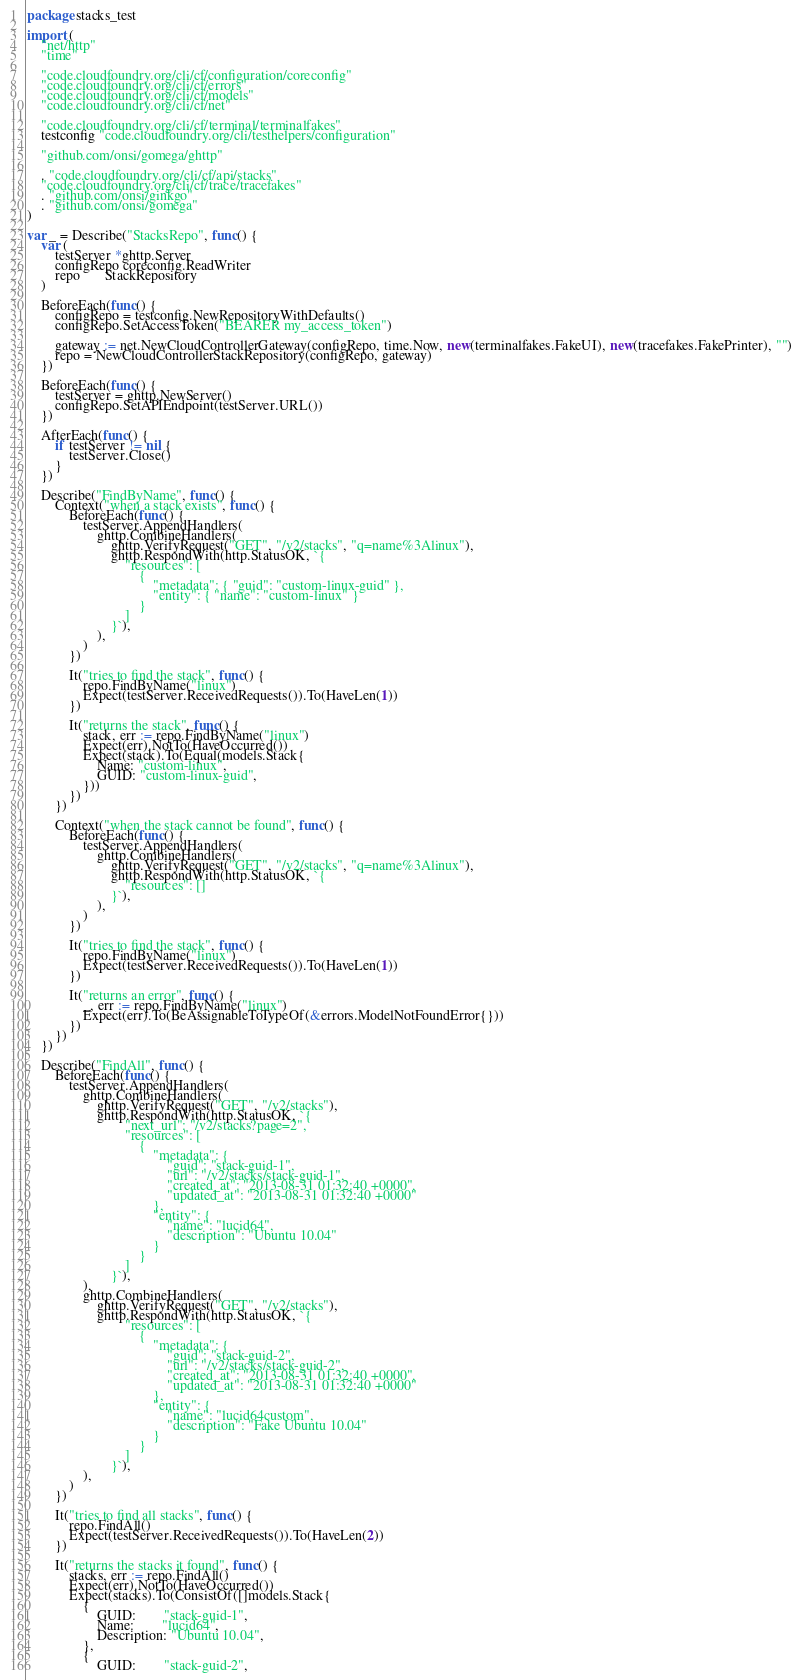Convert code to text. <code><loc_0><loc_0><loc_500><loc_500><_Go_>package stacks_test

import (
	"net/http"
	"time"

	"code.cloudfoundry.org/cli/cf/configuration/coreconfig"
	"code.cloudfoundry.org/cli/cf/errors"
	"code.cloudfoundry.org/cli/cf/models"
	"code.cloudfoundry.org/cli/cf/net"

	"code.cloudfoundry.org/cli/cf/terminal/terminalfakes"
	testconfig "code.cloudfoundry.org/cli/testhelpers/configuration"

	"github.com/onsi/gomega/ghttp"

	. "code.cloudfoundry.org/cli/cf/api/stacks"
	"code.cloudfoundry.org/cli/cf/trace/tracefakes"
	. "github.com/onsi/ginkgo"
	. "github.com/onsi/gomega"
)

var _ = Describe("StacksRepo", func() {
	var (
		testServer *ghttp.Server
		configRepo coreconfig.ReadWriter
		repo       StackRepository
	)

	BeforeEach(func() {
		configRepo = testconfig.NewRepositoryWithDefaults()
		configRepo.SetAccessToken("BEARER my_access_token")

		gateway := net.NewCloudControllerGateway(configRepo, time.Now, new(terminalfakes.FakeUI), new(tracefakes.FakePrinter), "")
		repo = NewCloudControllerStackRepository(configRepo, gateway)
	})

	BeforeEach(func() {
		testServer = ghttp.NewServer()
		configRepo.SetAPIEndpoint(testServer.URL())
	})

	AfterEach(func() {
		if testServer != nil {
			testServer.Close()
		}
	})

	Describe("FindByName", func() {
		Context("when a stack exists", func() {
			BeforeEach(func() {
				testServer.AppendHandlers(
					ghttp.CombineHandlers(
						ghttp.VerifyRequest("GET", "/v2/stacks", "q=name%3Alinux"),
						ghttp.RespondWith(http.StatusOK, `{
							"resources": [
								{
									"metadata": { "guid": "custom-linux-guid" },
									"entity": { "name": "custom-linux" }
								}
							]
						}`),
					),
				)
			})

			It("tries to find the stack", func() {
				repo.FindByName("linux")
				Expect(testServer.ReceivedRequests()).To(HaveLen(1))
			})

			It("returns the stack", func() {
				stack, err := repo.FindByName("linux")
				Expect(err).NotTo(HaveOccurred())
				Expect(stack).To(Equal(models.Stack{
					Name: "custom-linux",
					GUID: "custom-linux-guid",
				}))
			})
		})

		Context("when the stack cannot be found", func() {
			BeforeEach(func() {
				testServer.AppendHandlers(
					ghttp.CombineHandlers(
						ghttp.VerifyRequest("GET", "/v2/stacks", "q=name%3Alinux"),
						ghttp.RespondWith(http.StatusOK, `{
							"resources": []
						}`),
					),
				)
			})

			It("tries to find the stack", func() {
				repo.FindByName("linux")
				Expect(testServer.ReceivedRequests()).To(HaveLen(1))
			})

			It("returns an error", func() {
				_, err := repo.FindByName("linux")
				Expect(err).To(BeAssignableToTypeOf(&errors.ModelNotFoundError{}))
			})
		})
	})

	Describe("FindAll", func() {
		BeforeEach(func() {
			testServer.AppendHandlers(
				ghttp.CombineHandlers(
					ghttp.VerifyRequest("GET", "/v2/stacks"),
					ghttp.RespondWith(http.StatusOK, `{
							"next_url": "/v2/stacks?page=2",
							"resources": [
								{
									"metadata": {
										"guid": "stack-guid-1",
										"url": "/v2/stacks/stack-guid-1",
										"created_at": "2013-08-31 01:32:40 +0000",
										"updated_at": "2013-08-31 01:32:40 +0000"
									},
									"entity": {
										"name": "lucid64",
										"description": "Ubuntu 10.04"
									}
								}
							]
						}`),
				),
				ghttp.CombineHandlers(
					ghttp.VerifyRequest("GET", "/v2/stacks"),
					ghttp.RespondWith(http.StatusOK, `{
							"resources": [
								{
									"metadata": {
										"guid": "stack-guid-2",
										"url": "/v2/stacks/stack-guid-2",
										"created_at": "2013-08-31 01:32:40 +0000",
										"updated_at": "2013-08-31 01:32:40 +0000"
									},
									"entity": {
										"name": "lucid64custom",
										"description": "Fake Ubuntu 10.04"
									}
								}
							]
						}`),
				),
			)
		})

		It("tries to find all stacks", func() {
			repo.FindAll()
			Expect(testServer.ReceivedRequests()).To(HaveLen(2))
		})

		It("returns the stacks it found", func() {
			stacks, err := repo.FindAll()
			Expect(err).NotTo(HaveOccurred())
			Expect(stacks).To(ConsistOf([]models.Stack{
				{
					GUID:        "stack-guid-1",
					Name:        "lucid64",
					Description: "Ubuntu 10.04",
				},
				{
					GUID:        "stack-guid-2",</code> 